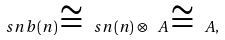Convert formula to latex. <formula><loc_0><loc_0><loc_500><loc_500>\ s n b ( n ) \cong \ s n ( n ) \otimes \ A \cong \ A ,</formula> 